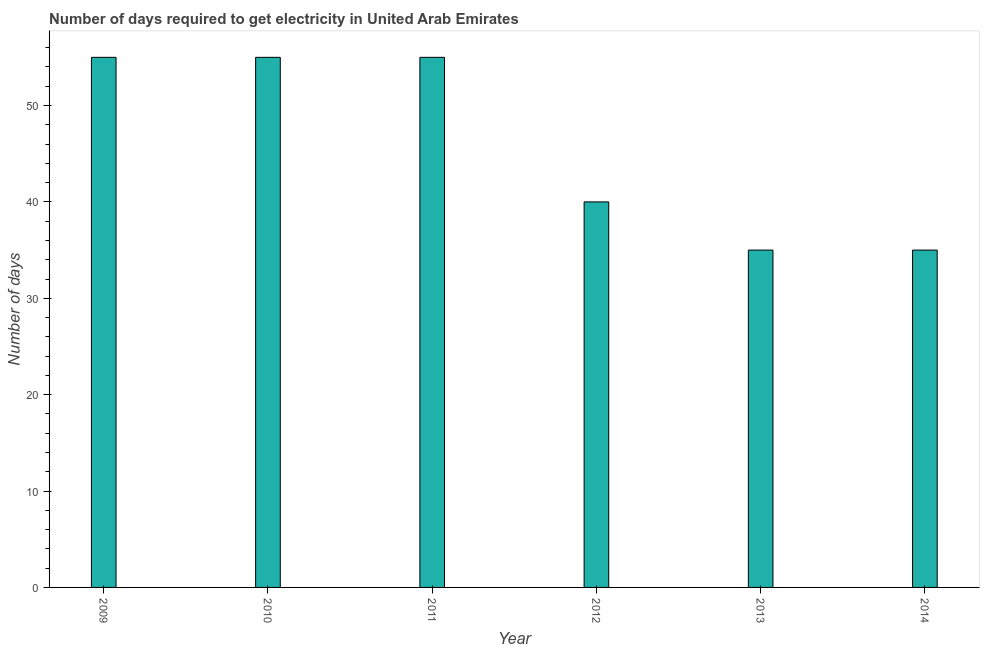What is the title of the graph?
Your response must be concise. Number of days required to get electricity in United Arab Emirates. What is the label or title of the Y-axis?
Provide a short and direct response. Number of days. What is the time to get electricity in 2012?
Provide a succinct answer. 40. Across all years, what is the minimum time to get electricity?
Offer a terse response. 35. In which year was the time to get electricity minimum?
Your answer should be compact. 2013. What is the sum of the time to get electricity?
Your response must be concise. 275. What is the average time to get electricity per year?
Your answer should be compact. 45. What is the median time to get electricity?
Provide a succinct answer. 47.5. In how many years, is the time to get electricity greater than 16 ?
Your answer should be compact. 6. Do a majority of the years between 2010 and 2013 (inclusive) have time to get electricity greater than 42 ?
Provide a succinct answer. No. What is the ratio of the time to get electricity in 2013 to that in 2014?
Offer a very short reply. 1. Is the time to get electricity in 2012 less than that in 2013?
Your answer should be very brief. No. Is the sum of the time to get electricity in 2010 and 2012 greater than the maximum time to get electricity across all years?
Keep it short and to the point. Yes. What is the difference between the highest and the lowest time to get electricity?
Ensure brevity in your answer.  20. In how many years, is the time to get electricity greater than the average time to get electricity taken over all years?
Give a very brief answer. 3. How many years are there in the graph?
Ensure brevity in your answer.  6. What is the difference between two consecutive major ticks on the Y-axis?
Your answer should be compact. 10. Are the values on the major ticks of Y-axis written in scientific E-notation?
Make the answer very short. No. What is the Number of days in 2009?
Offer a very short reply. 55. What is the Number of days of 2010?
Make the answer very short. 55. What is the difference between the Number of days in 2009 and 2013?
Your answer should be compact. 20. What is the difference between the Number of days in 2010 and 2011?
Offer a terse response. 0. What is the difference between the Number of days in 2011 and 2013?
Offer a terse response. 20. What is the difference between the Number of days in 2012 and 2013?
Provide a succinct answer. 5. What is the difference between the Number of days in 2013 and 2014?
Your answer should be compact. 0. What is the ratio of the Number of days in 2009 to that in 2010?
Ensure brevity in your answer.  1. What is the ratio of the Number of days in 2009 to that in 2012?
Your response must be concise. 1.38. What is the ratio of the Number of days in 2009 to that in 2013?
Give a very brief answer. 1.57. What is the ratio of the Number of days in 2009 to that in 2014?
Offer a very short reply. 1.57. What is the ratio of the Number of days in 2010 to that in 2011?
Offer a terse response. 1. What is the ratio of the Number of days in 2010 to that in 2012?
Your answer should be compact. 1.38. What is the ratio of the Number of days in 2010 to that in 2013?
Your response must be concise. 1.57. What is the ratio of the Number of days in 2010 to that in 2014?
Your answer should be very brief. 1.57. What is the ratio of the Number of days in 2011 to that in 2012?
Your response must be concise. 1.38. What is the ratio of the Number of days in 2011 to that in 2013?
Your response must be concise. 1.57. What is the ratio of the Number of days in 2011 to that in 2014?
Make the answer very short. 1.57. What is the ratio of the Number of days in 2012 to that in 2013?
Offer a terse response. 1.14. What is the ratio of the Number of days in 2012 to that in 2014?
Make the answer very short. 1.14. What is the ratio of the Number of days in 2013 to that in 2014?
Keep it short and to the point. 1. 